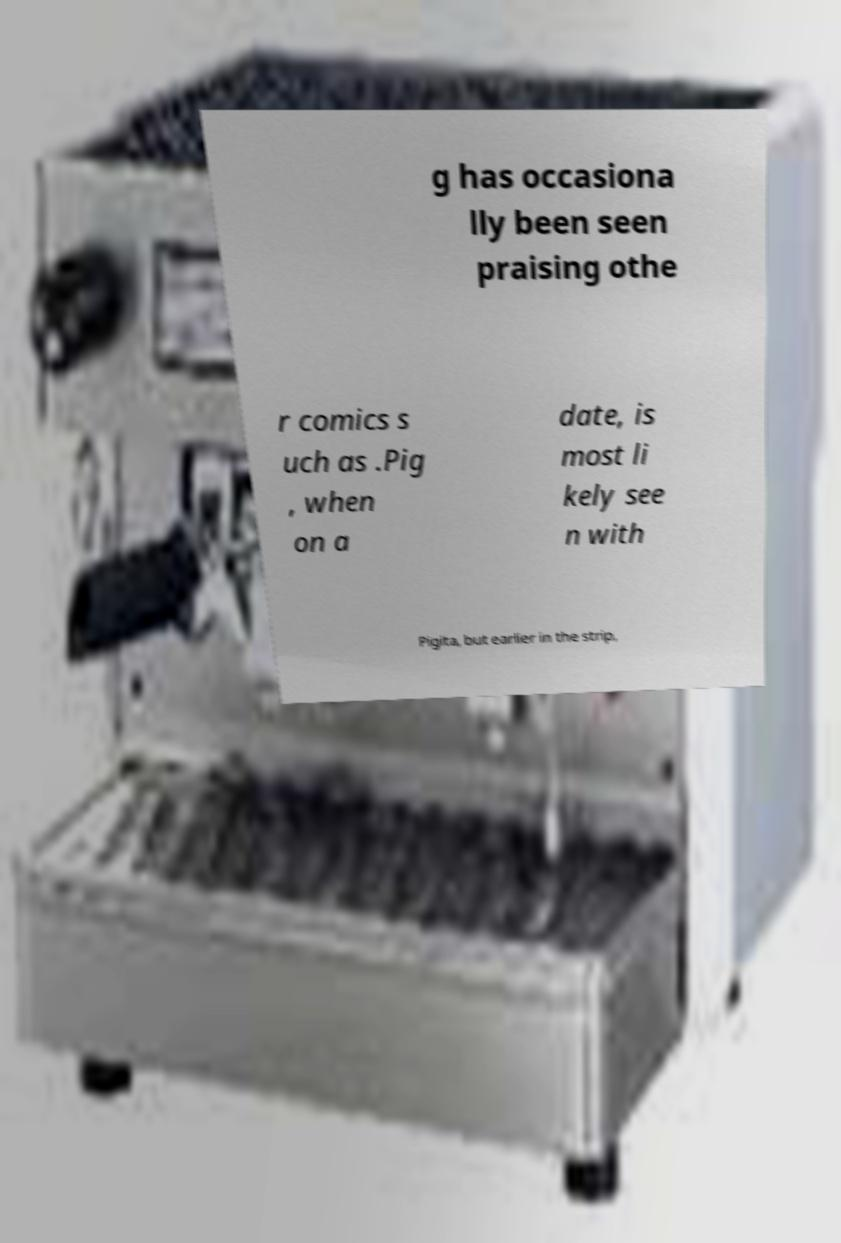There's text embedded in this image that I need extracted. Can you transcribe it verbatim? g has occasiona lly been seen praising othe r comics s uch as .Pig , when on a date, is most li kely see n with Pigita, but earlier in the strip, 